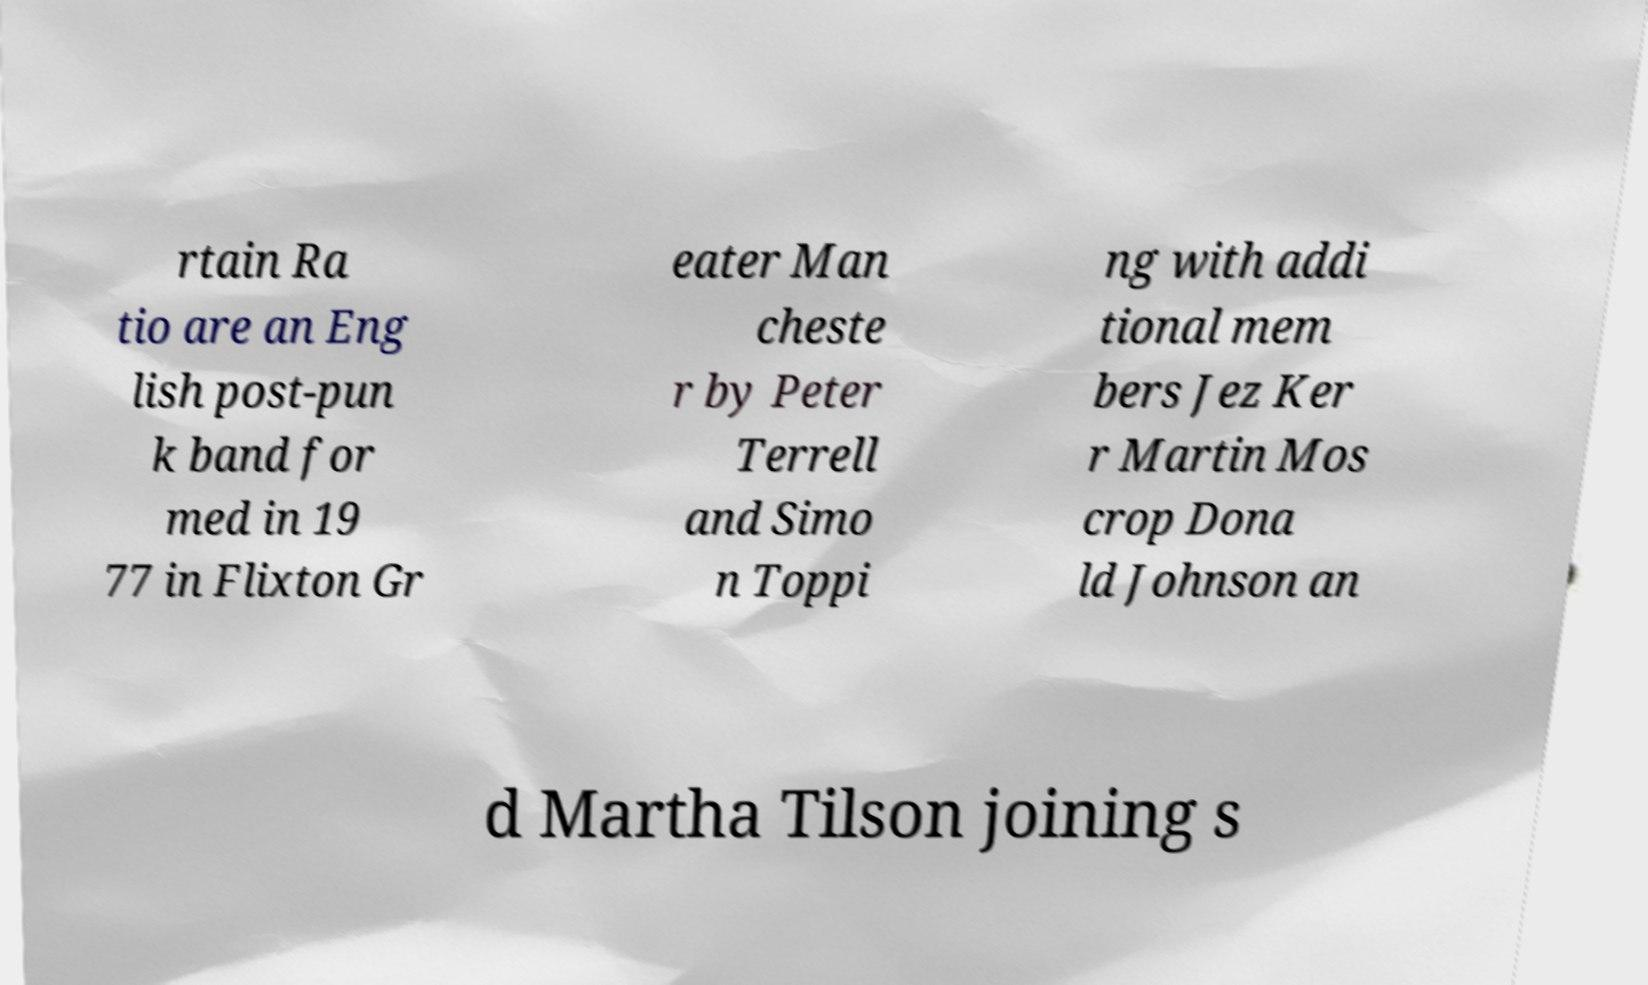For documentation purposes, I need the text within this image transcribed. Could you provide that? rtain Ra tio are an Eng lish post-pun k band for med in 19 77 in Flixton Gr eater Man cheste r by Peter Terrell and Simo n Toppi ng with addi tional mem bers Jez Ker r Martin Mos crop Dona ld Johnson an d Martha Tilson joining s 